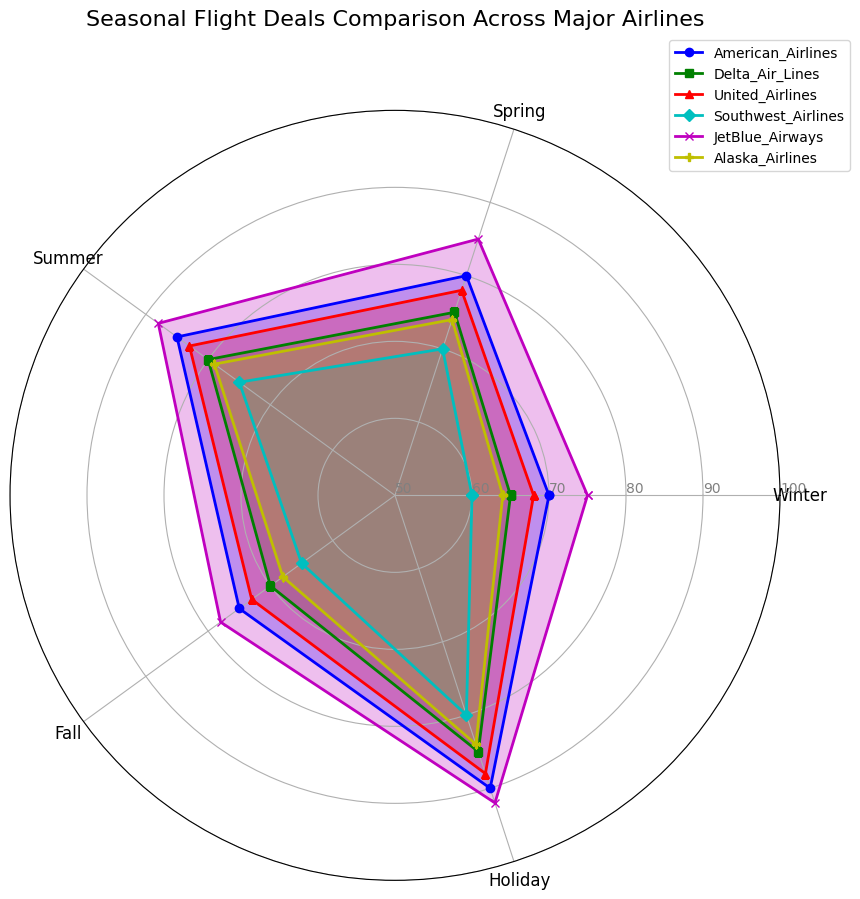Which airline offers the most favorable flight deals during the Holiday season? From the radar chart, identify which airline has the highest value at the Holiday datapoint. The (light pink colored) value from JetBlue Airways is the highest among all with 92.
Answer: JetBlue Airways During which season does American Airlines offer its highest flight deals? Locate the highest value on the American Airlines’ (blue colored) plot and identify the associated season. The highest value aligns with the Holiday season at 90.
Answer: Holiday Comparing Winter and Summer, does Southwest Airlines offer better flight deals in one over the other? Locate the values for Winter (60) and Summer (75) on Southwest Airlines’ (cyan colored) line. Summer’s value is higher, indicating better flight deals.
Answer: Summer Which airline shows the most drastic improvement from Fall to Holiday season? Calculate the difference between Fall and Holiday values for each airline. The airline with the largest positive change is JetBlue Airways, improving from 78 to 92, an increase of 14 points.
Answer: JetBlue Airways On average, which season offers the best flight deals across all airlines for Spring and Fall? Calculate the average values for Spring (80+75+78+70+85+74=462, 462/6=77) and Fall (75+70+73+65+78+68=429, 429/6=71.5). Therefore, Spring has a better average deal.
Answer: Spring Is there any season where all airlines have their lowest values compared to other seasons? Verify if for any single season, all values are lower when compared to other seasonal values for each airline. Winter has the lowest values for Delta, United, Southwest, and Alaska airlines.
Answer: Winter Which two seasons have the closest flight deal values for American Airlines? Compare the values for all seasons for American Airlines (70, 80, 85, 75, 90) and identify the two closest values, which are in Winter (70) and Fall (75), differing by 5 points.
Answer: Winter and Fall If you were to choose between Delta and Alaska Airlines primarily based on Spring and Summer deals, which airline offers better deals? Compare the Spring and Summer values from Delta (75 and 80) and Alaska Airlines (74 and 79). Delta consistently offers slightly better values each season.
Answer: Delta Air Lines For the entire year, which airline consistently provides higher flight deals across all seasons relative to United Airlines? Compare seasonal values for United Airlines vs each other airline. JetBlue Airways consistently has higher values than United in Winter (75 vs 68), Spring (85 vs 78), Summer (88 vs 83), Fall (78 vs 73), and Holiday (92 vs 88).
Answer: JetBlue Airways Which airline has the least variation in their flight deals throughout the seasons? Calculate and compare the ranges (max-min values) for each airline and find the lowest range. Southwest Airlines has values (60, 70, 75, 65, 80), resulting in the range being 20, the smallest variation.
Answer: Southwest Airlines 